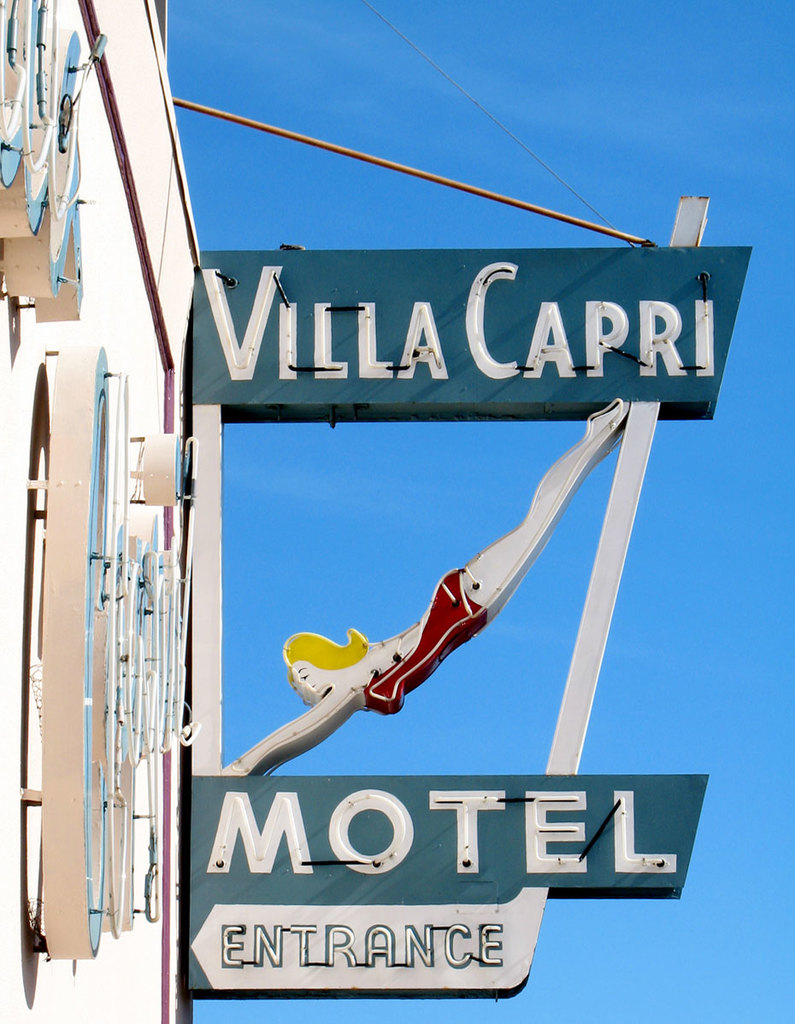What era does the design of this motel sign likely represent, and why is it significant? The design of the Villa Capri Motel sign suggests it's from the mid-20th century, particularly reflective of the 1950s or 1960s—a period known as the golden age of American road travel. This era saw a boom in the creation of motels, with distinctive signage designed to catch the eyes of motorists. The motifs, like the mermaid and the dynamic arrow shape, embody the optimism and whimsical design trends of the time. Signage like this is significant as it encapsulates a slice of cultural history, marking a time of economic prosperity and the rise of popular culture in post-war America. 